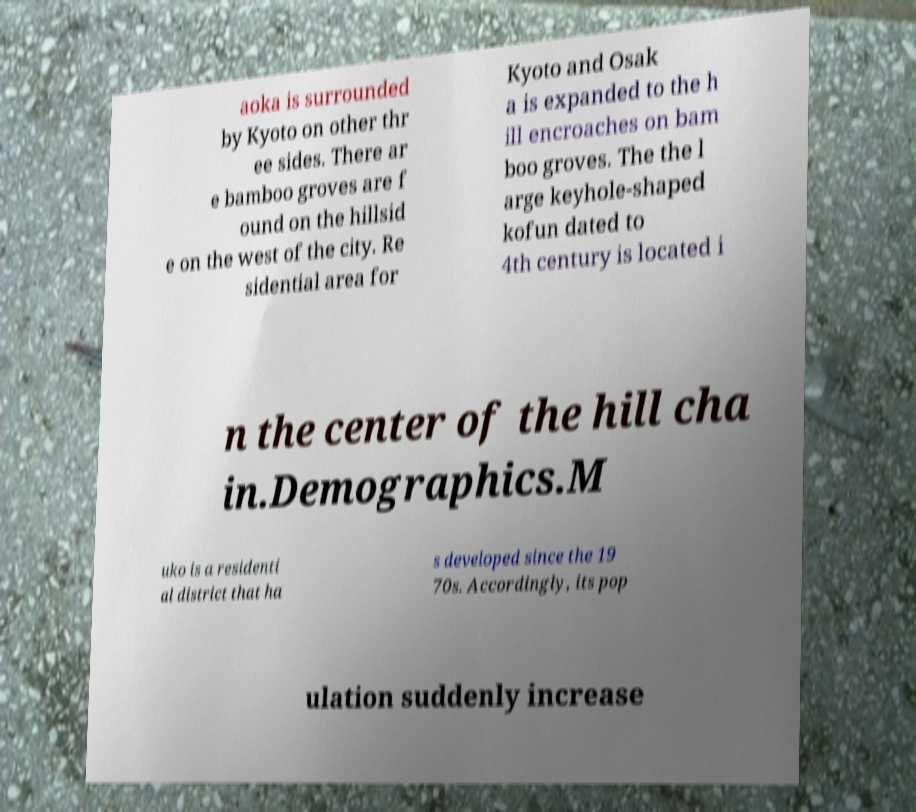Can you accurately transcribe the text from the provided image for me? aoka is surrounded by Kyoto on other thr ee sides. There ar e bamboo groves are f ound on the hillsid e on the west of the city. Re sidential area for Kyoto and Osak a is expanded to the h ill encroaches on bam boo groves. The the l arge keyhole-shaped kofun dated to 4th century is located i n the center of the hill cha in.Demographics.M uko is a residenti al district that ha s developed since the 19 70s. Accordingly, its pop ulation suddenly increase 